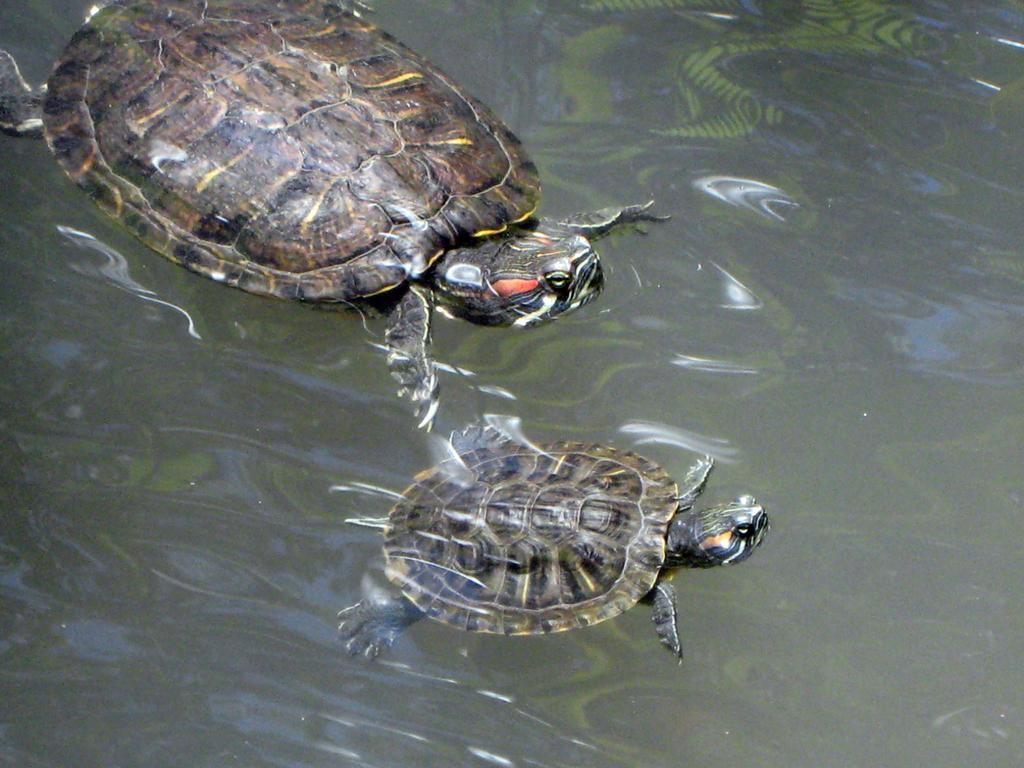Describe this image in one or two sentences. In the image in the center we can see two tortoise in water. 